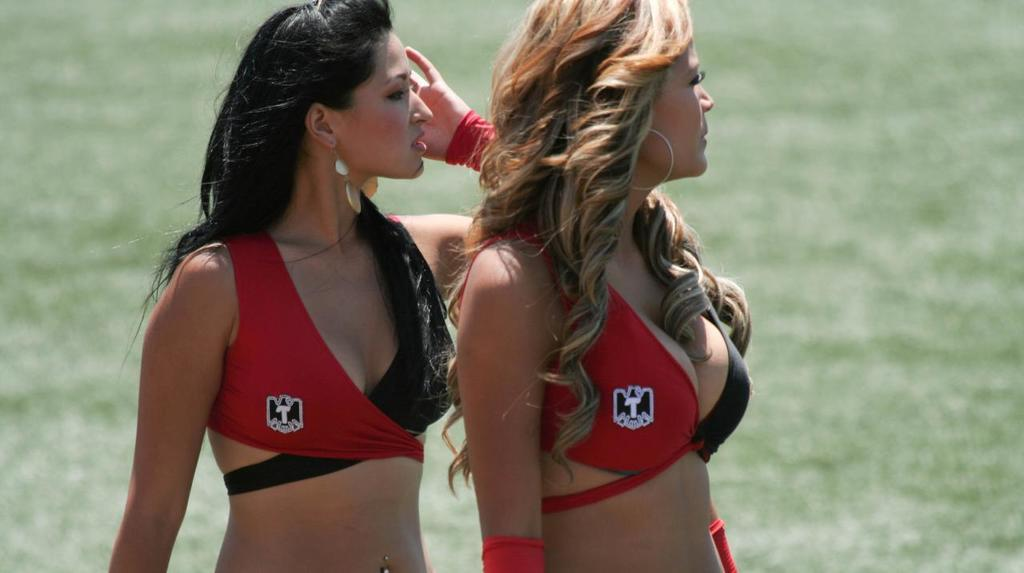<image>
Write a terse but informative summary of the picture. Two women with the letter T on their tops look off to the side. 